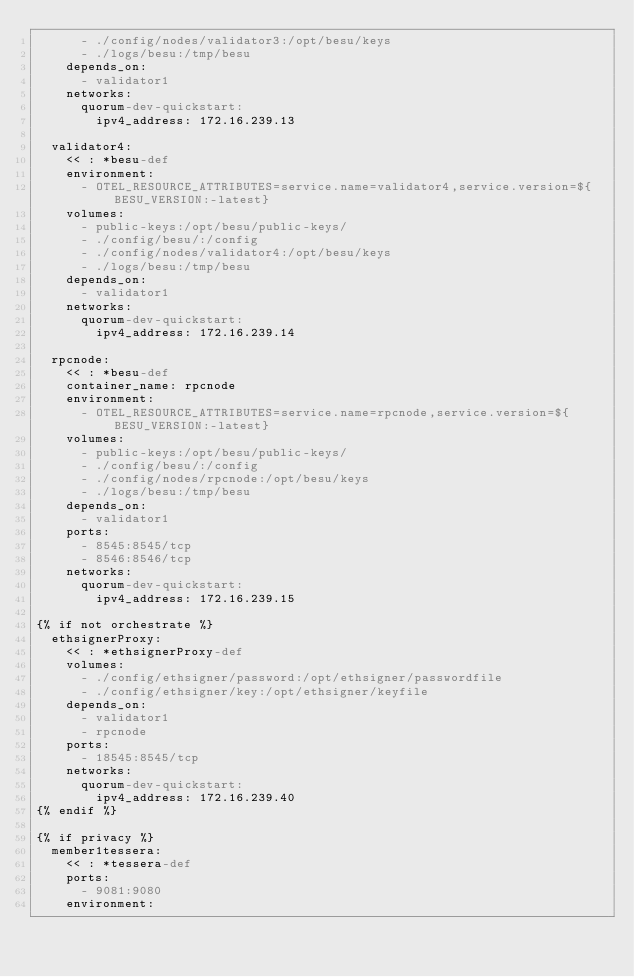<code> <loc_0><loc_0><loc_500><loc_500><_YAML_>      - ./config/nodes/validator3:/opt/besu/keys
      - ./logs/besu:/tmp/besu
    depends_on:
      - validator1
    networks:
      quorum-dev-quickstart:
        ipv4_address: 172.16.239.13

  validator4:
    << : *besu-def
    environment:
      - OTEL_RESOURCE_ATTRIBUTES=service.name=validator4,service.version=${BESU_VERSION:-latest}
    volumes:
      - public-keys:/opt/besu/public-keys/
      - ./config/besu/:/config
      - ./config/nodes/validator4:/opt/besu/keys
      - ./logs/besu:/tmp/besu
    depends_on:
      - validator1
    networks:
      quorum-dev-quickstart:
        ipv4_address: 172.16.239.14

  rpcnode:
    << : *besu-def
    container_name: rpcnode
    environment:
      - OTEL_RESOURCE_ATTRIBUTES=service.name=rpcnode,service.version=${BESU_VERSION:-latest}
    volumes:
      - public-keys:/opt/besu/public-keys/
      - ./config/besu/:/config
      - ./config/nodes/rpcnode:/opt/besu/keys
      - ./logs/besu:/tmp/besu
    depends_on:
      - validator1
    ports:
      - 8545:8545/tcp
      - 8546:8546/tcp
    networks:
      quorum-dev-quickstart:
        ipv4_address: 172.16.239.15

{% if not orchestrate %}
  ethsignerProxy:
    << : *ethsignerProxy-def
    volumes:
      - ./config/ethsigner/password:/opt/ethsigner/passwordfile
      - ./config/ethsigner/key:/opt/ethsigner/keyfile
    depends_on:
      - validator1
      - rpcnode
    ports:
      - 18545:8545/tcp
    networks:
      quorum-dev-quickstart:
        ipv4_address: 172.16.239.40
{% endif %}

{% if privacy %}
  member1tessera:
    << : *tessera-def
    ports:
      - 9081:9080
    environment:</code> 